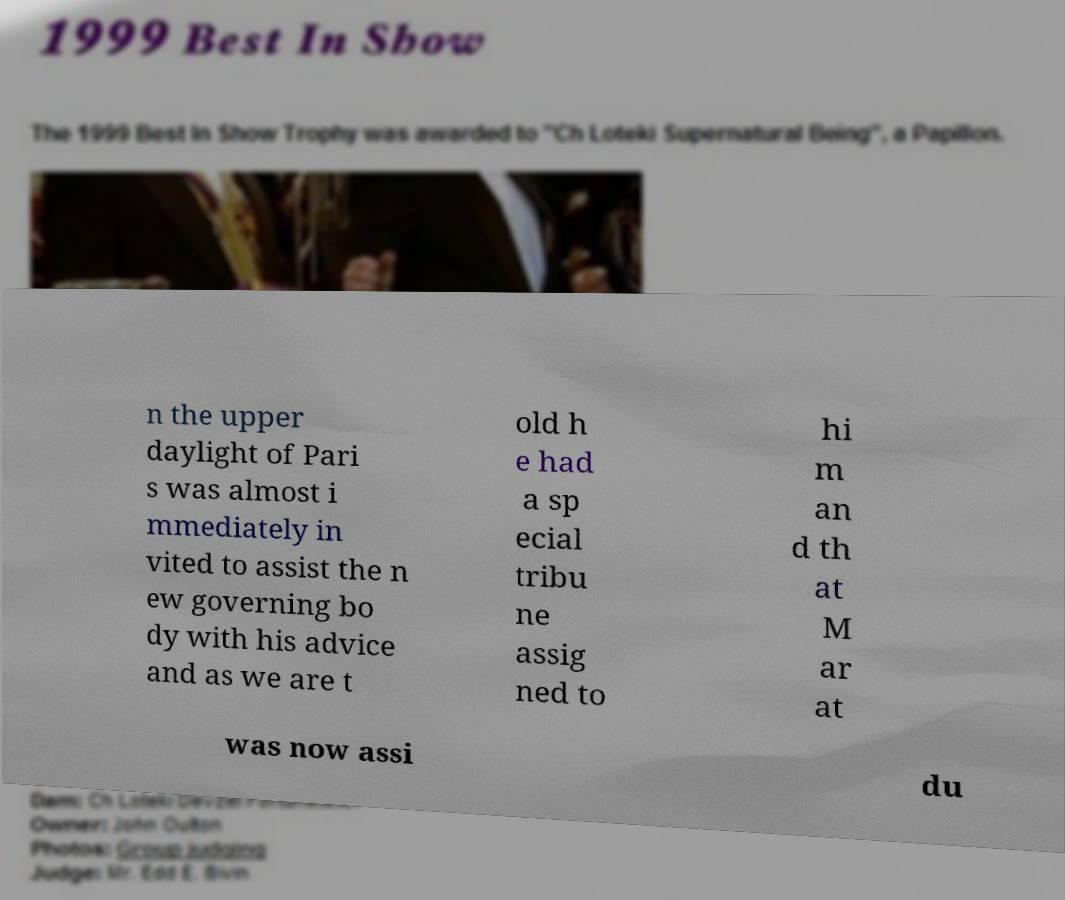There's text embedded in this image that I need extracted. Can you transcribe it verbatim? n the upper daylight of Pari s was almost i mmediately in vited to assist the n ew governing bo dy with his advice and as we are t old h e had a sp ecial tribu ne assig ned to hi m an d th at M ar at was now assi du 